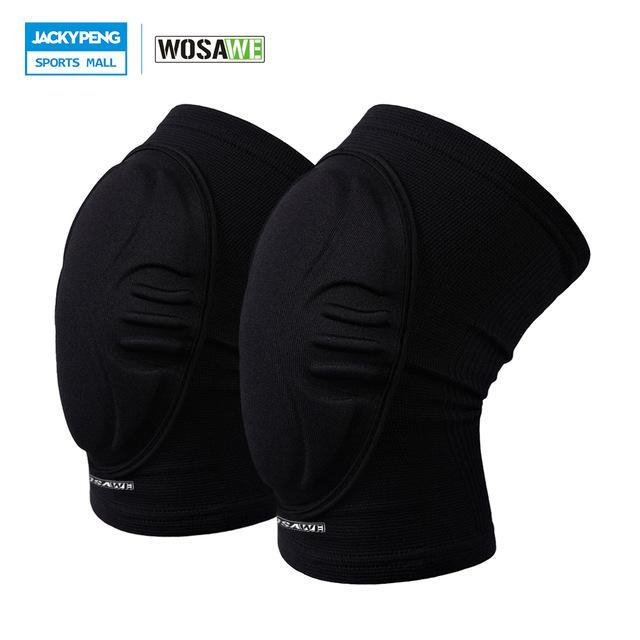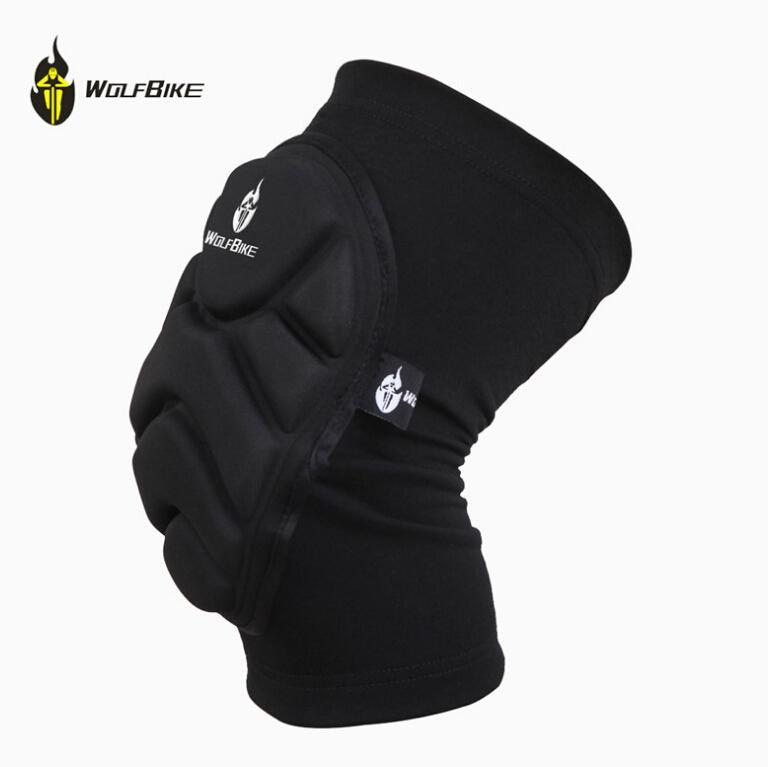The first image is the image on the left, the second image is the image on the right. Assess this claim about the two images: "There are 3 knee braces in the images.". Correct or not? Answer yes or no. Yes. The first image is the image on the left, the second image is the image on the right. Given the left and right images, does the statement "There are three knee pads." hold true? Answer yes or no. Yes. 